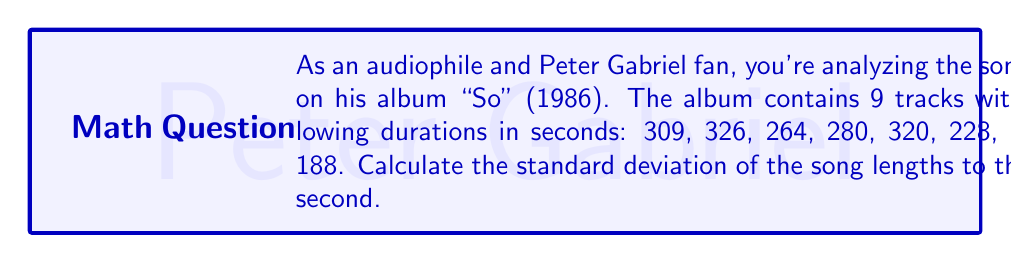What is the answer to this math problem? To calculate the standard deviation, we'll follow these steps:

1. Calculate the mean ($\mu$) of the song lengths:
   $$\mu = \frac{309 + 326 + 264 + 280 + 320 + 228 + 307 + 427 + 188}{9} = 294.33$$

2. Calculate the squared differences from the mean:
   $$(309 - 294.33)^2 = 215.11$$
   $$(326 - 294.33)^2 = 1001.78$$
   $$(264 - 294.33)^2 = 919.11$$
   $$(280 - 294.33)^2 = 205.44$$
   $$(320 - 294.33)^2 = 658.78$$
   $$(228 - 294.33)^2 = 4396.11$$
   $$(307 - 294.33)^2 = 160.44$$
   $$(427 - 294.33)^2 = 17600.44$$
   $$(188 - 294.33)^2 = 11304.11$$

3. Calculate the variance ($\sigma^2$):
   $$\sigma^2 = \frac{215.11 + 1001.78 + 919.11 + 205.44 + 658.78 + 4396.11 + 160.44 + 17600.44 + 11304.11}{9} = 4051.26$$

4. Calculate the standard deviation ($\sigma$):
   $$\sigma = \sqrt{4051.26} = 63.65$$

5. Round to the nearest second:
   $$\sigma \approx 64$$
Answer: 64 seconds 